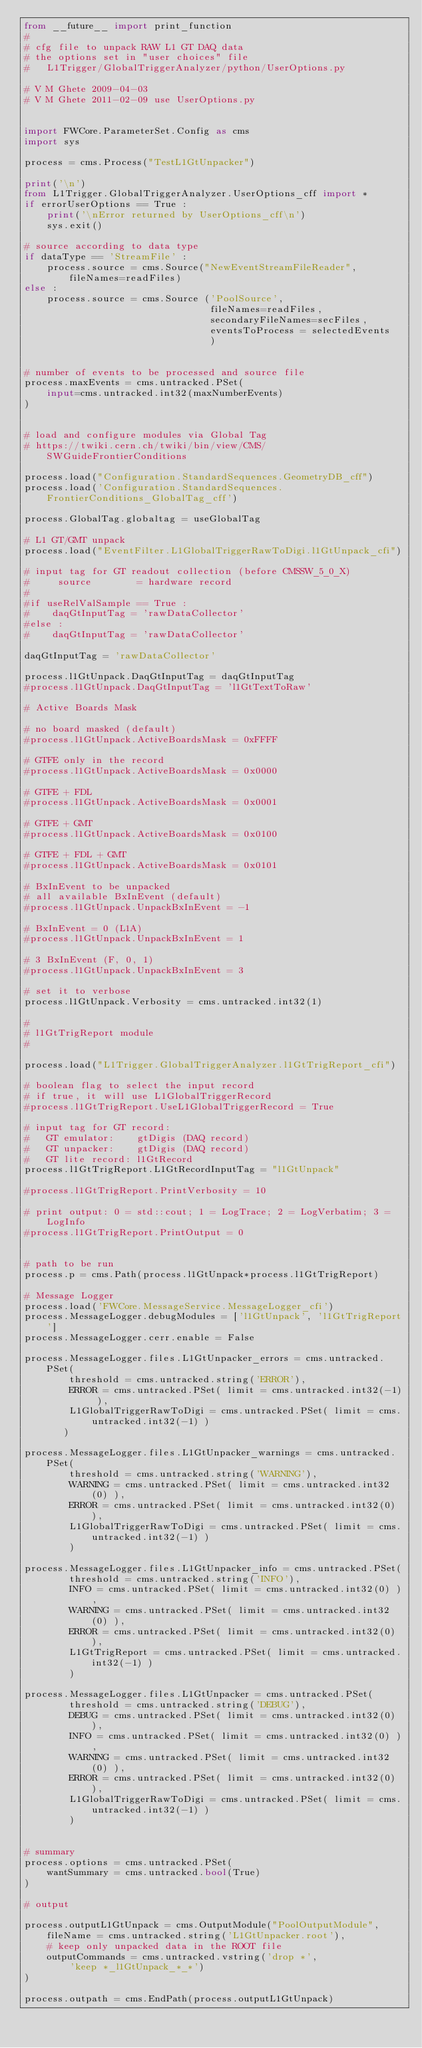<code> <loc_0><loc_0><loc_500><loc_500><_Python_>from __future__ import print_function
#
# cfg file to unpack RAW L1 GT DAQ data
# the options set in "user choices" file
#   L1Trigger/GlobalTriggerAnalyzer/python/UserOptions.py
 
# V M Ghete 2009-04-03
# V M Ghete 2011-02-09 use UserOptions.py

 
import FWCore.ParameterSet.Config as cms
import sys

process = cms.Process("TestL1GtUnpacker")

print('\n')
from L1Trigger.GlobalTriggerAnalyzer.UserOptions_cff import *
if errorUserOptions == True :
    print('\nError returned by UserOptions_cff\n')
    sys.exit()

# source according to data type
if dataType == 'StreamFile' :
    process.source = cms.Source("NewEventStreamFileReader", fileNames=readFiles)
else :        
    process.source = cms.Source ('PoolSource', 
                                 fileNames=readFiles, 
                                 secondaryFileNames=secFiles,
                                 eventsToProcess = selectedEvents
                                 )


# number of events to be processed and source file
process.maxEvents = cms.untracked.PSet(
    input=cms.untracked.int32(maxNumberEvents)
)


# load and configure modules via Global Tag
# https://twiki.cern.ch/twiki/bin/view/CMS/SWGuideFrontierConditions

process.load("Configuration.StandardSequences.GeometryDB_cff")
process.load('Configuration.StandardSequences.FrontierConditions_GlobalTag_cff')

process.GlobalTag.globaltag = useGlobalTag

# L1 GT/GMT unpack
process.load("EventFilter.L1GlobalTriggerRawToDigi.l1GtUnpack_cfi")

# input tag for GT readout collection (before CMSSW_5_0_X)
#     source        = hardware record
#
#if useRelValSample == True :
#    daqGtInputTag = 'rawDataCollector'
#else :
#    daqGtInputTag = 'rawDataCollector'

daqGtInputTag = 'rawDataCollector'

process.l1GtUnpack.DaqGtInputTag = daqGtInputTag
#process.l1GtUnpack.DaqGtInputTag = 'l1GtTextToRaw'

# Active Boards Mask

# no board masked (default)
#process.l1GtUnpack.ActiveBoardsMask = 0xFFFF
    
# GTFE only in the record
#process.l1GtUnpack.ActiveBoardsMask = 0x0000

# GTFE + FDL 
#process.l1GtUnpack.ActiveBoardsMask = 0x0001
     
# GTFE + GMT 
#process.l1GtUnpack.ActiveBoardsMask = 0x0100

# GTFE + FDL + GMT 
#process.l1GtUnpack.ActiveBoardsMask = 0x0101

# BxInEvent to be unpacked
# all available BxInEvent (default)
#process.l1GtUnpack.UnpackBxInEvent = -1 

# BxInEvent = 0 (L1A)
#process.l1GtUnpack.UnpackBxInEvent = 1 

# 3 BxInEvent (F, 0, 1)  
#process.l1GtUnpack.UnpackBxInEvent = 3 

# set it to verbose
process.l1GtUnpack.Verbosity = cms.untracked.int32(1)

#
# l1GtTrigReport module
#

process.load("L1Trigger.GlobalTriggerAnalyzer.l1GtTrigReport_cfi")
 
# boolean flag to select the input record
# if true, it will use L1GlobalTriggerRecord 
#process.l1GtTrigReport.UseL1GlobalTriggerRecord = True

# input tag for GT record: 
#   GT emulator:    gtDigis (DAQ record)
#   GT unpacker:    gtDigis (DAQ record)
#   GT lite record: l1GtRecord 
process.l1GtTrigReport.L1GtRecordInputTag = "l1GtUnpack"

#process.l1GtTrigReport.PrintVerbosity = 10

# print output: 0 = std::cout; 1 = LogTrace; 2 = LogVerbatim; 3 = LogInfo
#process.l1GtTrigReport.PrintOutput = 0


# path to be run
process.p = cms.Path(process.l1GtUnpack*process.l1GtTrigReport)

# Message Logger
process.load('FWCore.MessageService.MessageLogger_cfi')
process.MessageLogger.debugModules = ['l1GtUnpack', 'l1GtTrigReport']
process.MessageLogger.cerr.enable = False

process.MessageLogger.files.L1GtUnpacker_errors = cms.untracked.PSet( 
        threshold = cms.untracked.string('ERROR'),
        ERROR = cms.untracked.PSet( limit = cms.untracked.int32(-1) ),
        L1GlobalTriggerRawToDigi = cms.untracked.PSet( limit = cms.untracked.int32(-1) ) 
       )

process.MessageLogger.files.L1GtUnpacker_warnings = cms.untracked.PSet( 
        threshold = cms.untracked.string('WARNING'),
        WARNING = cms.untracked.PSet( limit = cms.untracked.int32(0) ),
        ERROR = cms.untracked.PSet( limit = cms.untracked.int32(0) ),
        L1GlobalTriggerRawToDigi = cms.untracked.PSet( limit = cms.untracked.int32(-1) ) 
        )

process.MessageLogger.files.L1GtUnpacker_info = cms.untracked.PSet( 
        threshold = cms.untracked.string('INFO'),
        INFO = cms.untracked.PSet( limit = cms.untracked.int32(0) ),
        WARNING = cms.untracked.PSet( limit = cms.untracked.int32(0) ),
        ERROR = cms.untracked.PSet( limit = cms.untracked.int32(0) ),
        L1GtTrigReport = cms.untracked.PSet( limit = cms.untracked.int32(-1) ) 
        )

process.MessageLogger.files.L1GtUnpacker = cms.untracked.PSet( 
        threshold = cms.untracked.string('DEBUG'),
        DEBUG = cms.untracked.PSet( limit = cms.untracked.int32(0) ),
        INFO = cms.untracked.PSet( limit = cms.untracked.int32(0) ),
        WARNING = cms.untracked.PSet( limit = cms.untracked.int32(0) ),
        ERROR = cms.untracked.PSet( limit = cms.untracked.int32(0) ),
        L1GlobalTriggerRawToDigi = cms.untracked.PSet( limit = cms.untracked.int32(-1) ) 
        )


# summary
process.options = cms.untracked.PSet(
    wantSummary = cms.untracked.bool(True)
)

# output 

process.outputL1GtUnpack = cms.OutputModule("PoolOutputModule",
    fileName = cms.untracked.string('L1GtUnpacker.root'),
    # keep only unpacked data in the ROOT file
    outputCommands = cms.untracked.vstring('drop *', 
        'keep *_l1GtUnpack_*_*')
)

process.outpath = cms.EndPath(process.outputL1GtUnpack)

</code> 